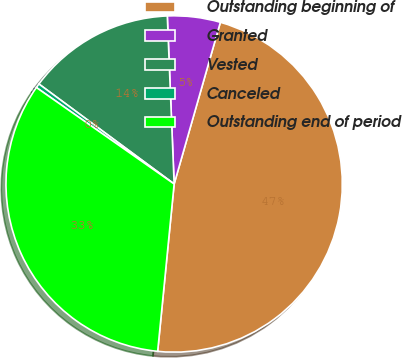<chart> <loc_0><loc_0><loc_500><loc_500><pie_chart><fcel>Outstanding beginning of<fcel>Granted<fcel>Vested<fcel>Canceled<fcel>Outstanding end of period<nl><fcel>47.13%<fcel>5.08%<fcel>14.22%<fcel>0.41%<fcel>33.16%<nl></chart> 